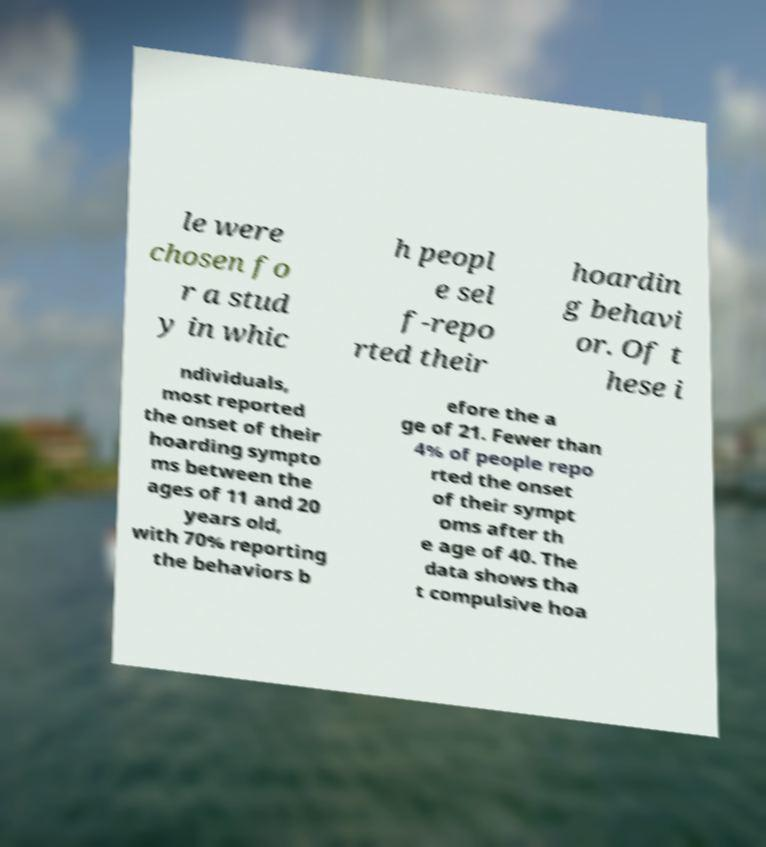Could you extract and type out the text from this image? le were chosen fo r a stud y in whic h peopl e sel f-repo rted their hoardin g behavi or. Of t hese i ndividuals, most reported the onset of their hoarding sympto ms between the ages of 11 and 20 years old, with 70% reporting the behaviors b efore the a ge of 21. Fewer than 4% of people repo rted the onset of their sympt oms after th e age of 40. The data shows tha t compulsive hoa 